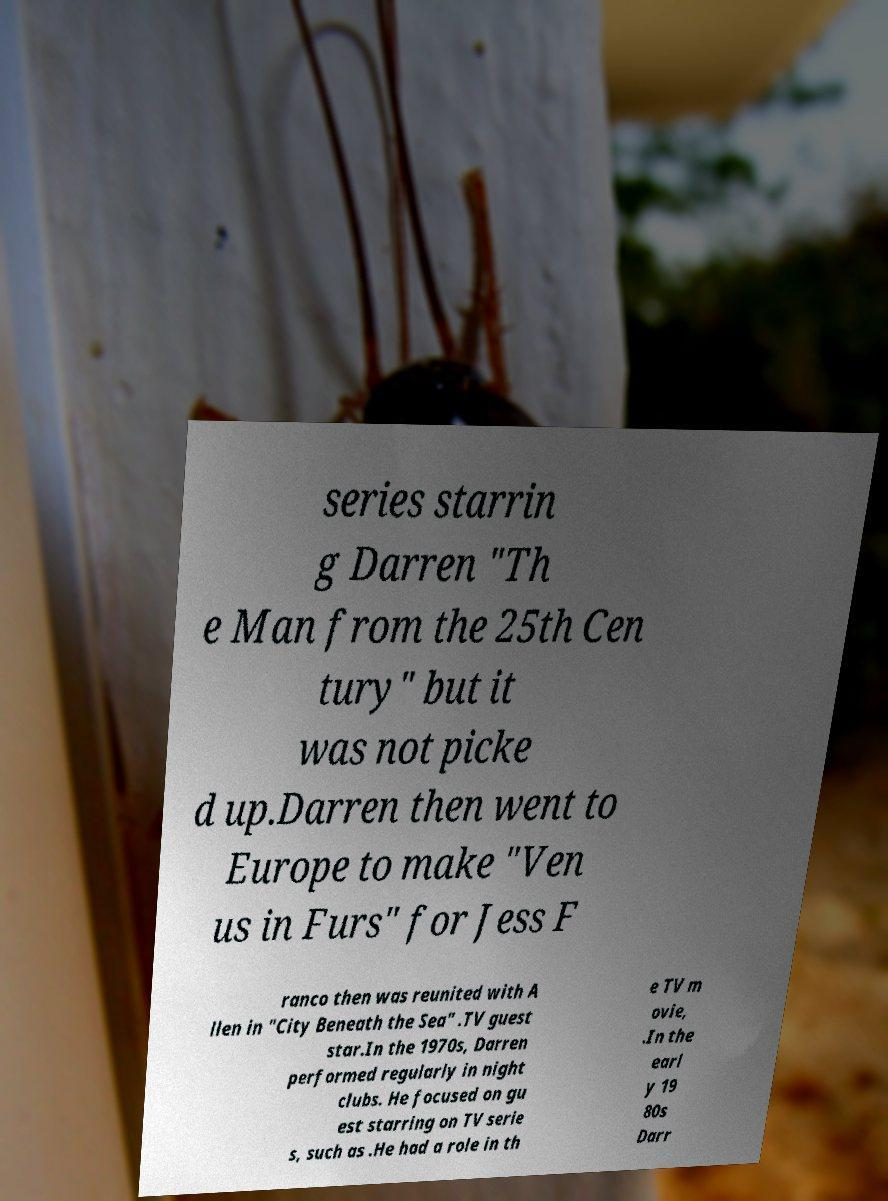What messages or text are displayed in this image? I need them in a readable, typed format. series starrin g Darren "Th e Man from the 25th Cen tury" but it was not picke d up.Darren then went to Europe to make "Ven us in Furs" for Jess F ranco then was reunited with A llen in "City Beneath the Sea" .TV guest star.In the 1970s, Darren performed regularly in night clubs. He focused on gu est starring on TV serie s, such as .He had a role in th e TV m ovie, .In the earl y 19 80s Darr 